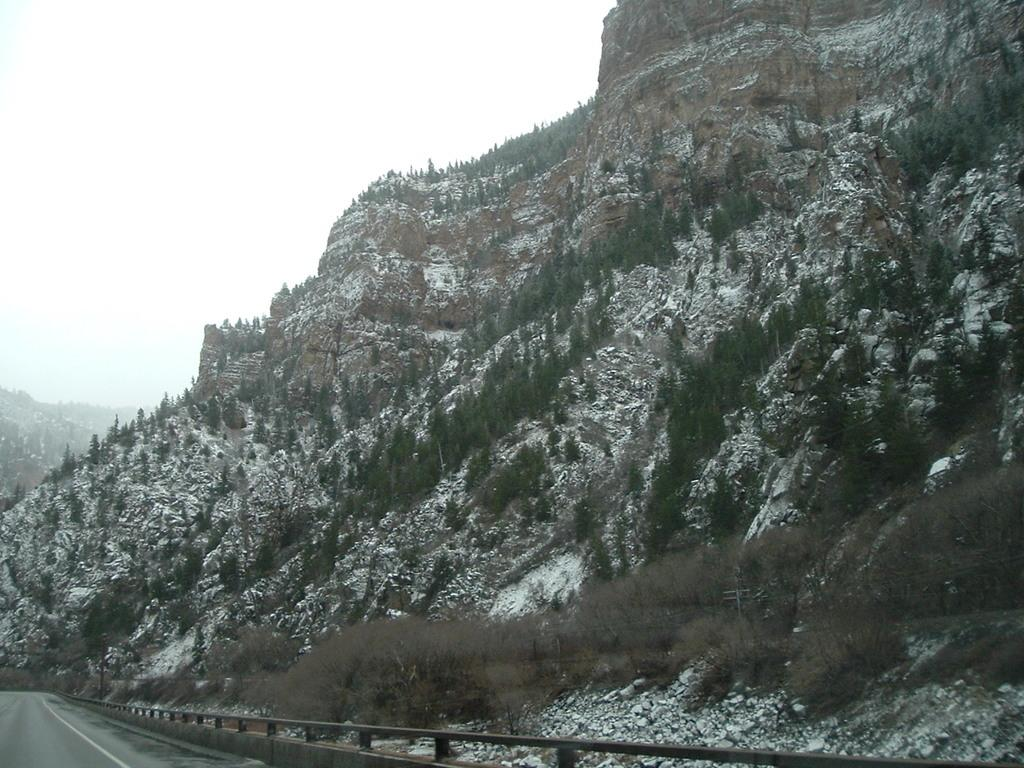What is the main feature in the center of the image? There is a mountain with trees in the center of the image. What can be seen on the left side, bottom of the image? There is a road on the left side, bottom of the image. What is visible at the top of the image? The sky is visible at the top of the image. What type of advertisement can be seen on the mountain in the image? There is no advertisement present on the mountain in the image; it features a mountain with trees. What color is the sheet draped over the trees in the image? There is no sheet present in the image; it features a mountain with trees. 